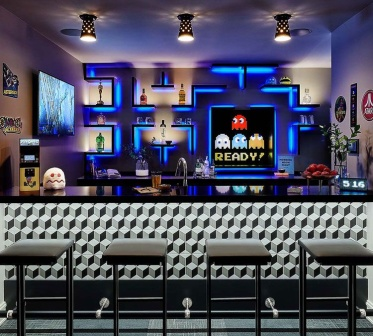Describe the mood and lighting of the bar during the late hours of the night. During the late hours of the night, the bar’s lighting becomes more subdued and intimate, with neon lights providing a soft, colorful glow. The play of shadows and lights creates a cozy and slightly mysterious atmosphere, perfect for unwinding. The faint humming of conversations and the clinking of glasses fill the air, complemented by retro tunes playing softly in the background. The ambiance feels timeless and relaxing, offering a sanctuary for night owls looking to unwind after a long day.  Invent a futuristic scenario for this bar in the year 2050. In the year 2050, Jack’s bar has evolved into the ultimate augmented reality arcade lounge. As patrons walk in, they don AR glasses provided at the entrance. Instantly, the bar transforms into an immersive Pac-Man universe where holographic mazes shift around them, and digital ghosts roam free. Patrons can engage in live-action Pac-Man games, sprinting to and from holographic pellets while avoiding AR ghosts. The drinks menu is interactive, allowing users to swipe through and customize their cocktails in real-time, which are then mixed by robotic bartenders. Even the classic neon lights have been upgraded to dynamic, floating displays that react to the user’s presence. The 2050 version of the bar still holds nostalgia at its core, blending it seamlessly with cutting-edge technology to offer an extraordinary social and gaming experience.  Who would frequent this bar and why? This bar would attract a diverse crowd including retro gaming enthusiasts, nostalgic adults looking to relive a piece of their childhood, and younger generations curious about classic games. It would also appeal to people who enjoy unique and themed social venues, as well as tourists seeking iconic places to visit. Its blend of vibrant ambiance, engaging activities, and delicious cocktails make it a hotspot for anyone looking for a memorable night out. 